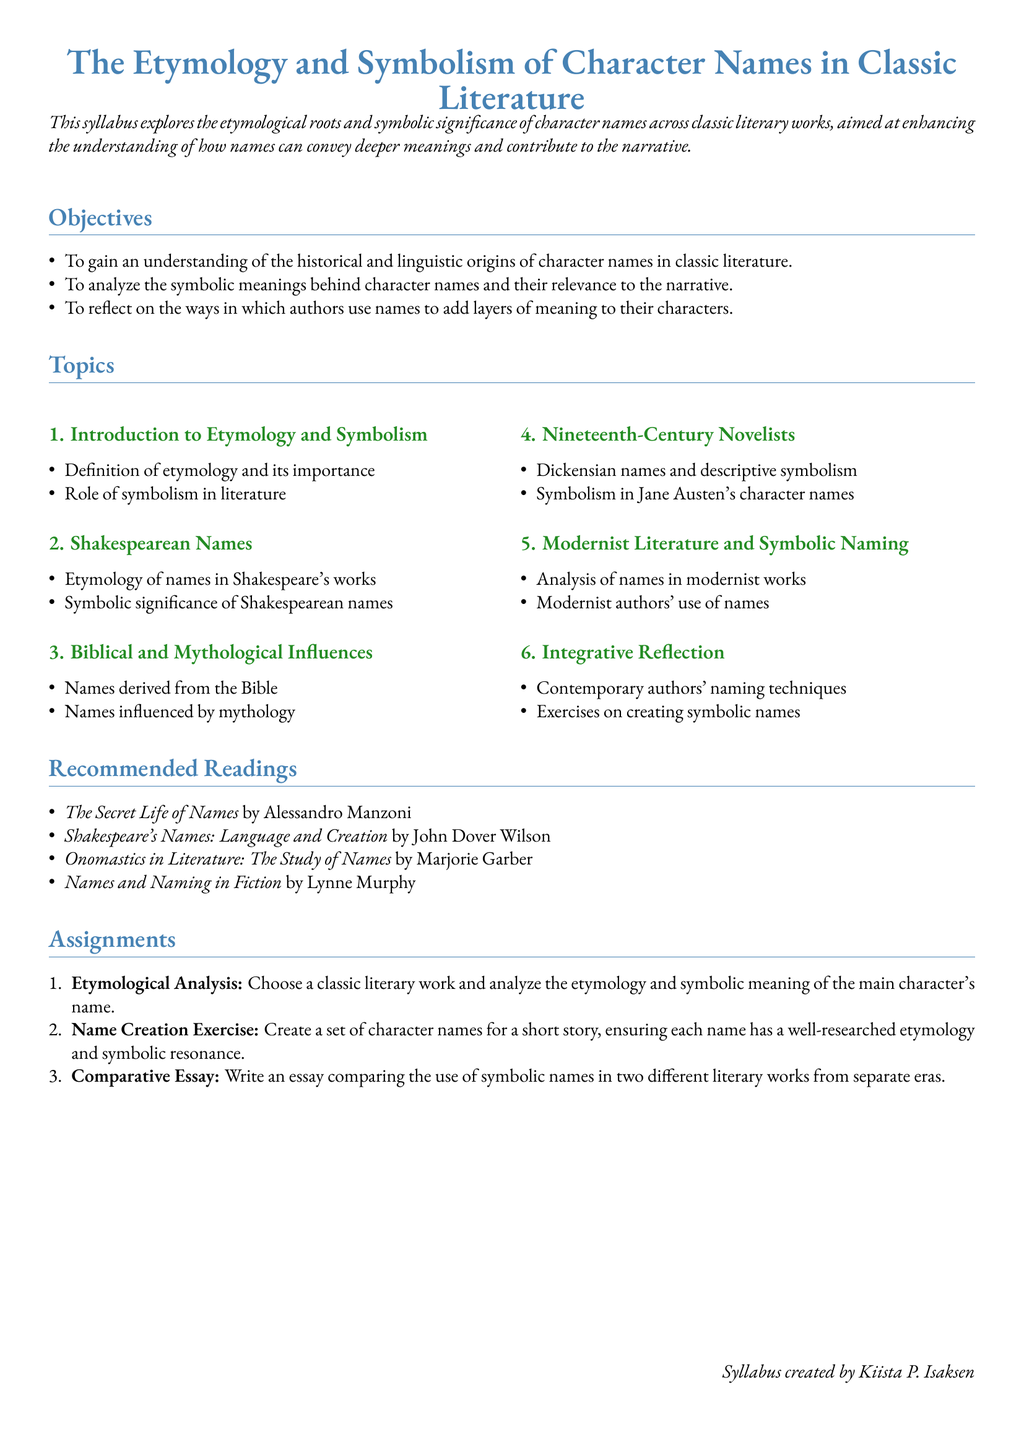What is the title of the syllabus? The title is the main subject of the syllabus, which focuses on the etymology and symbolism in literature.
Answer: The Etymology and Symbolism of Character Names in Classic Literature What is the first topic discussed in the syllabus? The first topic gives an introductory overview of etymology and symbolism in literature.
Answer: Introduction to Etymology and Symbolism Who is the author of "Onomastics in Literature: The Study of Names"? This is a specific recommended reading that mentions the author related to the study of names.
Answer: Marjorie Garber What is the total number of sections in the syllabus? The number of sections is indicative of the quantity of key areas covered related to character names.
Answer: Six What type of analysis is assigned in the first assignment? This assignment involves a detailed examination of etymology and symbolic meaning in literature.
Answer: Etymological Analysis Which literary period do Dickensian names belong to according to this syllabus? This question pertains to the specific time frame that the syllabus refers to in its topics.
Answer: Nineteenth Century What kind of exercise is included in the naming techniques section? This exercise encourages a creative approach to name creation with symbolic relevance.
Answer: Name Creation Exercise What is the main objective of the syllabus? This provides the primary aim of studying character names in classic literature.
Answer: To gain an understanding of the historical and linguistic origins of character names in classic literature What color is used for the section titles? The color used for the main titles reflects a certain aesthetic choice in the presentation of the document.
Answer: Blue 